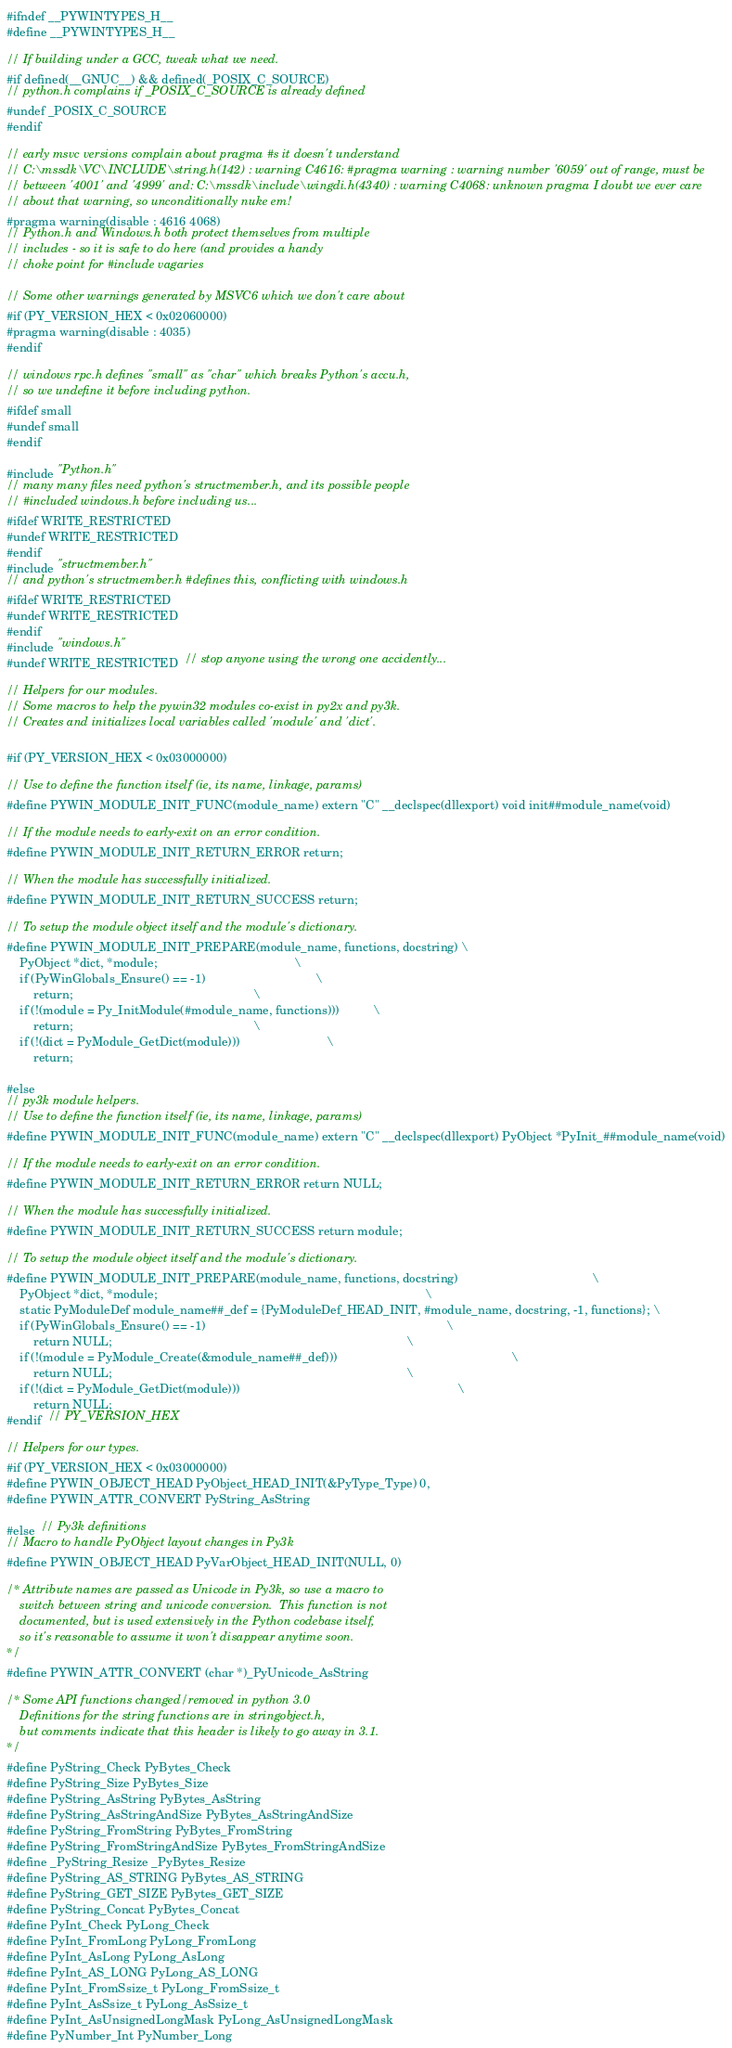<code> <loc_0><loc_0><loc_500><loc_500><_C_>
#ifndef __PYWINTYPES_H__
#define __PYWINTYPES_H__

// If building under a GCC, tweak what we need.
#if defined(__GNUC__) && defined(_POSIX_C_SOURCE)
// python.h complains if _POSIX_C_SOURCE is already defined
#undef _POSIX_C_SOURCE
#endif

// early msvc versions complain about pragma #s it doesn't understand
// C:\mssdk\VC\INCLUDE\string.h(142) : warning C4616: #pragma warning : warning number '6059' out of range, must be
// between '4001' and '4999' and: C:\mssdk\include\wingdi.h(4340) : warning C4068: unknown pragma I doubt we ever care
// about that warning, so unconditionally nuke em!
#pragma warning(disable : 4616 4068)
// Python.h and Windows.h both protect themselves from multiple
// includes - so it is safe to do here (and provides a handy
// choke point for #include vagaries

// Some other warnings generated by MSVC6 which we don't care about
#if (PY_VERSION_HEX < 0x02060000)
#pragma warning(disable : 4035)
#endif

// windows rpc.h defines "small" as "char" which breaks Python's accu.h,
// so we undefine it before including python.
#ifdef small
#undef small
#endif

#include "Python.h"
// many many files need python's structmember.h, and its possible people
// #included windows.h before including us...
#ifdef WRITE_RESTRICTED
#undef WRITE_RESTRICTED
#endif
#include "structmember.h"
// and python's structmember.h #defines this, conflicting with windows.h
#ifdef WRITE_RESTRICTED
#undef WRITE_RESTRICTED
#endif
#include "windows.h"
#undef WRITE_RESTRICTED  // stop anyone using the wrong one accidently...

// Helpers for our modules.
// Some macros to help the pywin32 modules co-exist in py2x and py3k.
// Creates and initializes local variables called 'module' and 'dict'.

#if (PY_VERSION_HEX < 0x03000000)

// Use to define the function itself (ie, its name, linkage, params)
#define PYWIN_MODULE_INIT_FUNC(module_name) extern "C" __declspec(dllexport) void init##module_name(void)

// If the module needs to early-exit on an error condition.
#define PYWIN_MODULE_INIT_RETURN_ERROR return;

// When the module has successfully initialized.
#define PYWIN_MODULE_INIT_RETURN_SUCCESS return;

// To setup the module object itself and the module's dictionary.
#define PYWIN_MODULE_INIT_PREPARE(module_name, functions, docstring) \
    PyObject *dict, *module;                                         \
    if (PyWinGlobals_Ensure() == -1)                                 \
        return;                                                      \
    if (!(module = Py_InitModule(#module_name, functions)))          \
        return;                                                      \
    if (!(dict = PyModule_GetDict(module)))                          \
        return;

#else
// py3k module helpers.
// Use to define the function itself (ie, its name, linkage, params)
#define PYWIN_MODULE_INIT_FUNC(module_name) extern "C" __declspec(dllexport) PyObject *PyInit_##module_name(void)

// If the module needs to early-exit on an error condition.
#define PYWIN_MODULE_INIT_RETURN_ERROR return NULL;

// When the module has successfully initialized.
#define PYWIN_MODULE_INIT_RETURN_SUCCESS return module;

// To setup the module object itself and the module's dictionary.
#define PYWIN_MODULE_INIT_PREPARE(module_name, functions, docstring)                                        \
    PyObject *dict, *module;                                                                                \
    static PyModuleDef module_name##_def = {PyModuleDef_HEAD_INIT, #module_name, docstring, -1, functions}; \
    if (PyWinGlobals_Ensure() == -1)                                                                        \
        return NULL;                                                                                        \
    if (!(module = PyModule_Create(&module_name##_def)))                                                    \
        return NULL;                                                                                        \
    if (!(dict = PyModule_GetDict(module)))                                                                 \
        return NULL;
#endif  // PY_VERSION_HEX

// Helpers for our types.
#if (PY_VERSION_HEX < 0x03000000)
#define PYWIN_OBJECT_HEAD PyObject_HEAD_INIT(&PyType_Type) 0,
#define PYWIN_ATTR_CONVERT PyString_AsString

#else  // Py3k definitions
// Macro to handle PyObject layout changes in Py3k
#define PYWIN_OBJECT_HEAD PyVarObject_HEAD_INIT(NULL, 0)

/* Attribute names are passed as Unicode in Py3k, so use a macro to
    switch between string and unicode conversion.  This function is not
    documented, but is used extensively in the Python codebase itself,
    so it's reasonable to assume it won't disappear anytime soon.
*/
#define PYWIN_ATTR_CONVERT (char *)_PyUnicode_AsString

/* Some API functions changed/removed in python 3.0
    Definitions for the string functions are in stringobject.h,
    but comments indicate that this header is likely to go away in 3.1.
*/
#define PyString_Check PyBytes_Check
#define PyString_Size PyBytes_Size
#define PyString_AsString PyBytes_AsString
#define PyString_AsStringAndSize PyBytes_AsStringAndSize
#define PyString_FromString PyBytes_FromString
#define PyString_FromStringAndSize PyBytes_FromStringAndSize
#define _PyString_Resize _PyBytes_Resize
#define PyString_AS_STRING PyBytes_AS_STRING
#define PyString_GET_SIZE PyBytes_GET_SIZE
#define PyString_Concat PyBytes_Concat
#define PyInt_Check PyLong_Check
#define PyInt_FromLong PyLong_FromLong
#define PyInt_AsLong PyLong_AsLong
#define PyInt_AS_LONG PyLong_AS_LONG
#define PyInt_FromSsize_t PyLong_FromSsize_t
#define PyInt_AsSsize_t PyLong_AsSsize_t
#define PyInt_AsUnsignedLongMask PyLong_AsUnsignedLongMask
#define PyNumber_Int PyNumber_Long</code> 